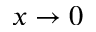<formula> <loc_0><loc_0><loc_500><loc_500>x \to 0</formula> 